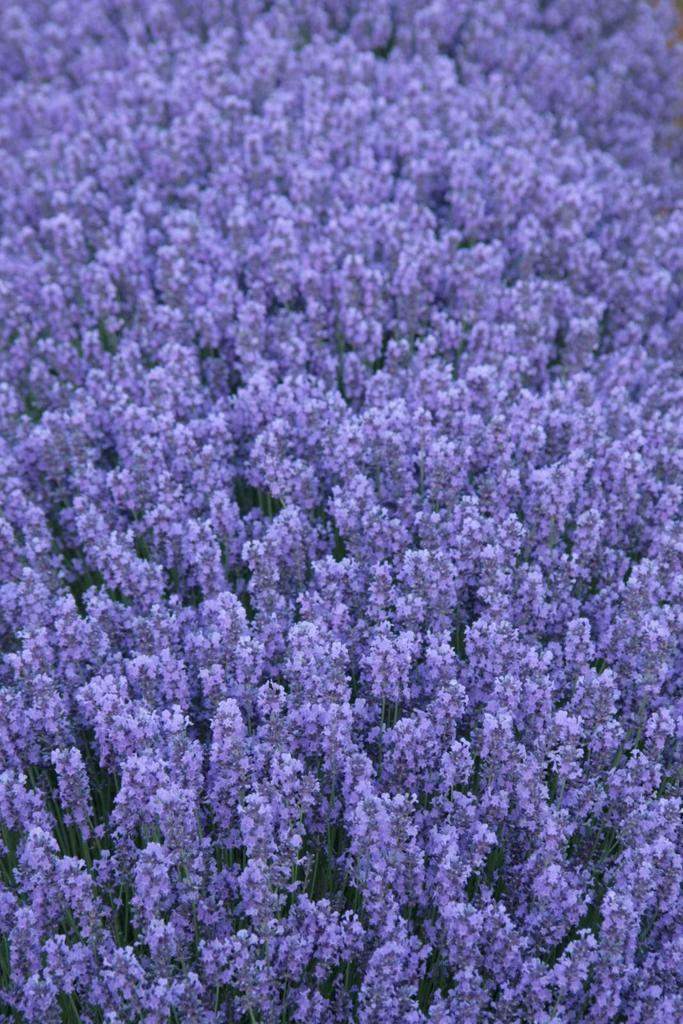What type of living organisms can be seen in the image? Plants can be seen in the image. What part of the plants is visible in the image? Leaves are visible in the image. What type of fuel is being used by the kitty in the image? There is no kitty present in the image, and therefore no fuel usage can be observed. 